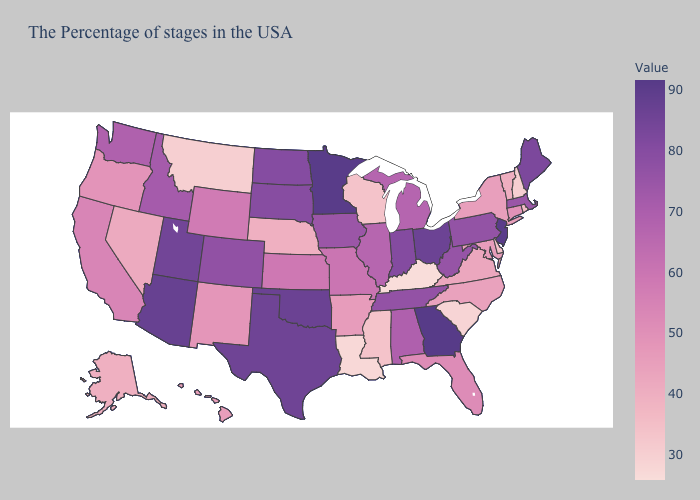Among the states that border North Dakota , which have the highest value?
Write a very short answer. Minnesota. Does Minnesota have the highest value in the MidWest?
Answer briefly. Yes. Does Georgia have the highest value in the USA?
Concise answer only. Yes. Is the legend a continuous bar?
Write a very short answer. Yes. Does the map have missing data?
Write a very short answer. No. Does Georgia have the highest value in the USA?
Give a very brief answer. Yes. Which states have the highest value in the USA?
Keep it brief. Georgia. 